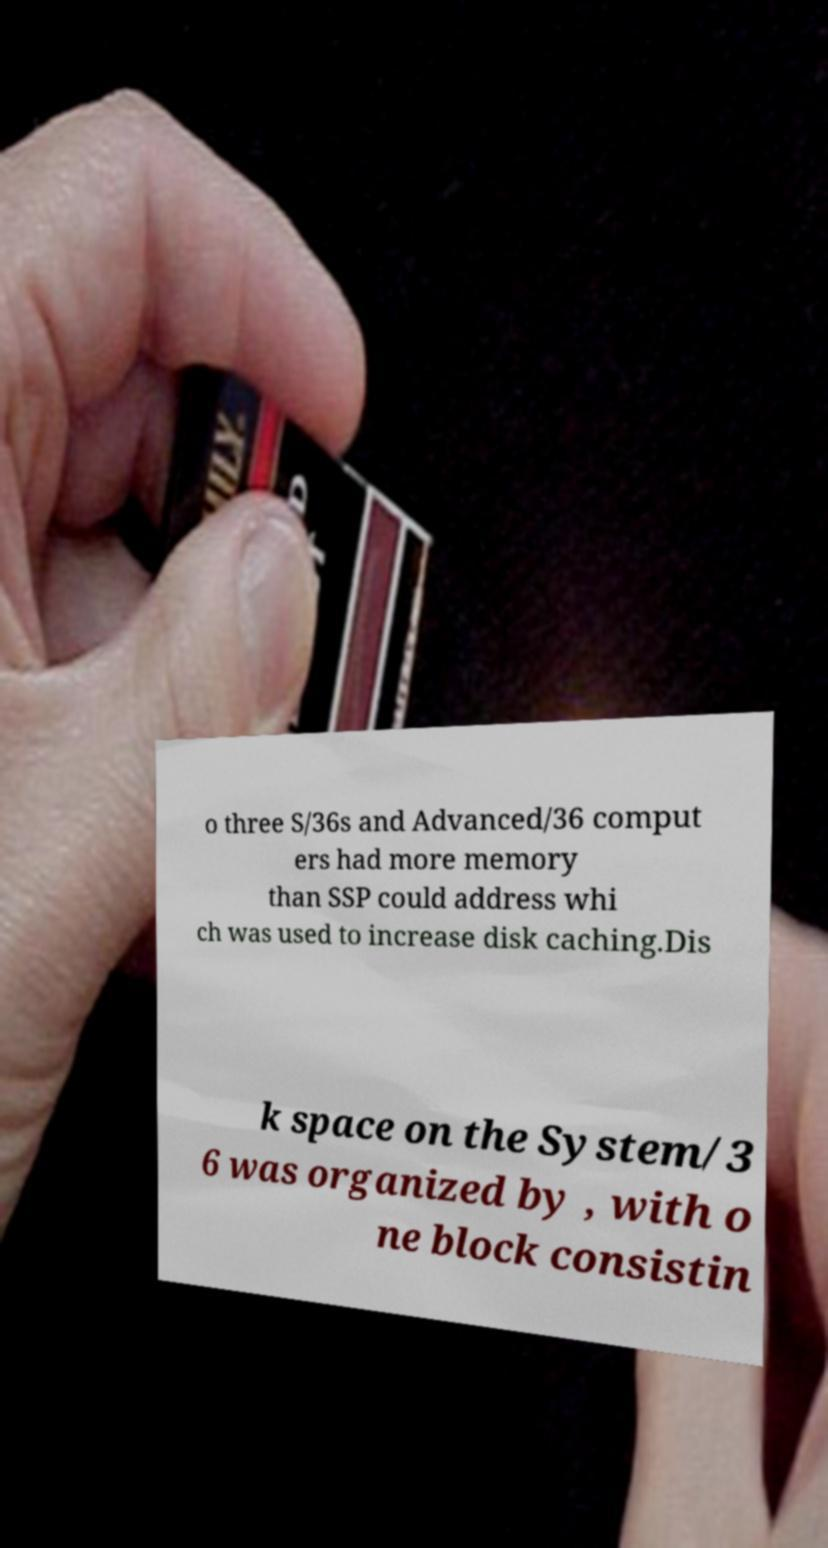I need the written content from this picture converted into text. Can you do that? o three S/36s and Advanced/36 comput ers had more memory than SSP could address whi ch was used to increase disk caching.Dis k space on the System/3 6 was organized by , with o ne block consistin 